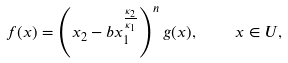<formula> <loc_0><loc_0><loc_500><loc_500>f ( x ) = \left ( x _ { 2 } - b x _ { 1 } ^ { \frac { \kappa _ { 2 } } { \kappa _ { 1 } } } \right ) ^ { n } g ( x ) , \quad x \in U ,</formula> 